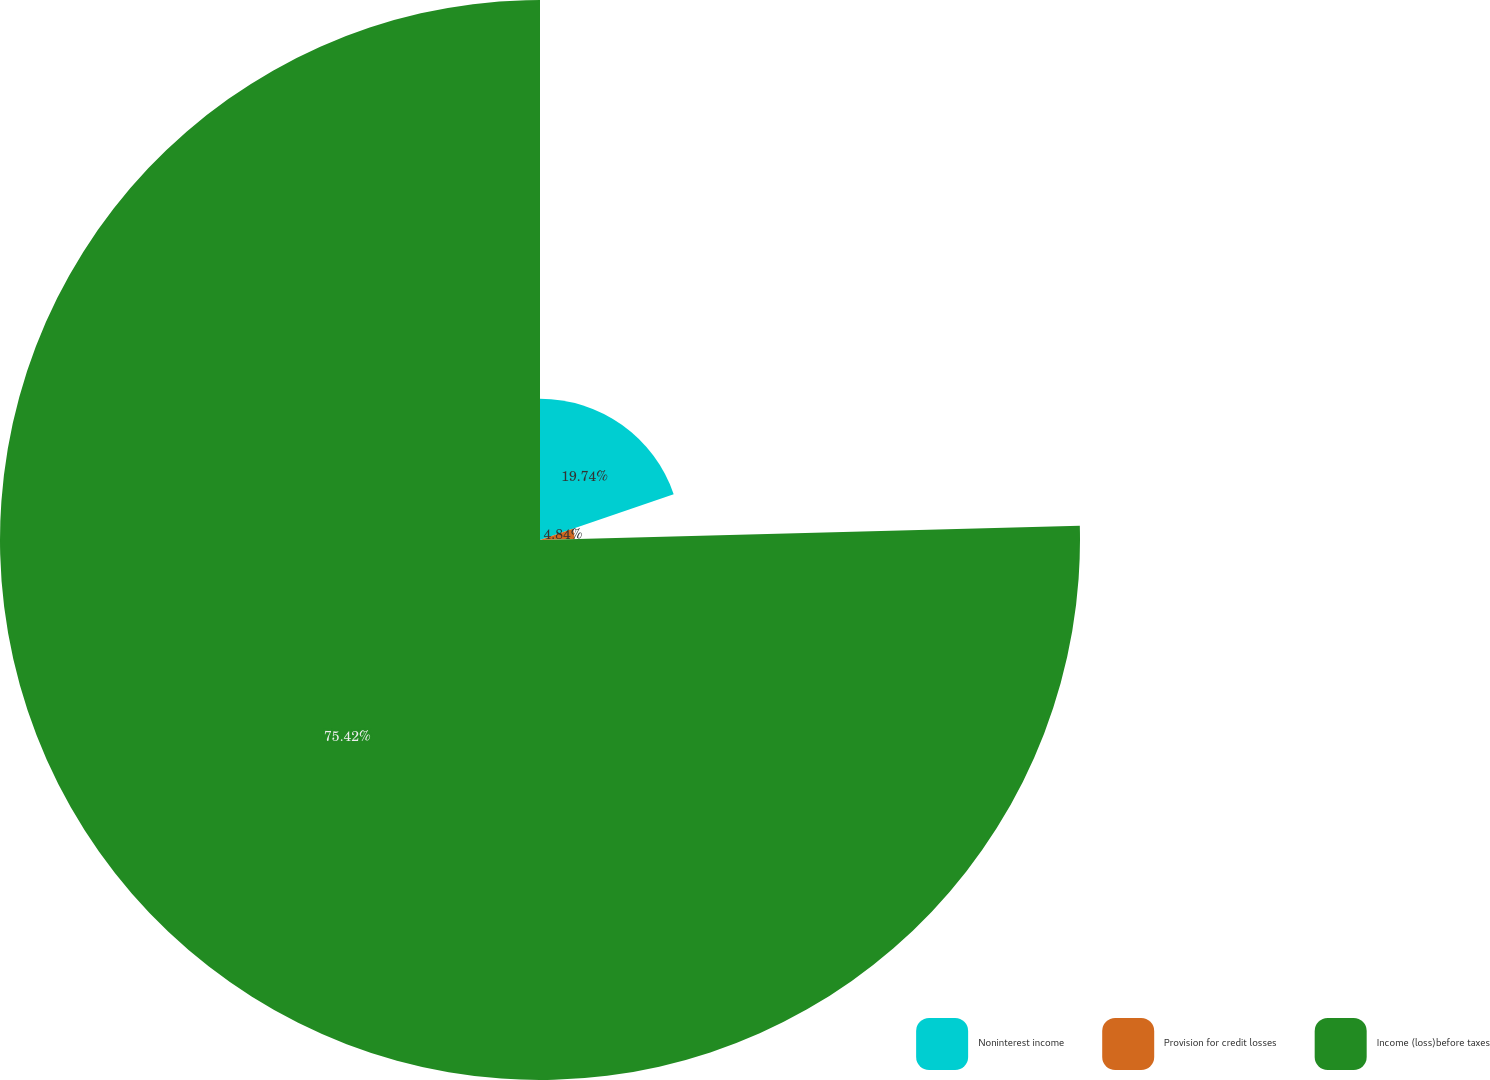Convert chart to OTSL. <chart><loc_0><loc_0><loc_500><loc_500><pie_chart><fcel>Noninterest income<fcel>Provision for credit losses<fcel>Income (loss)before taxes<nl><fcel>19.74%<fcel>4.84%<fcel>75.42%<nl></chart> 